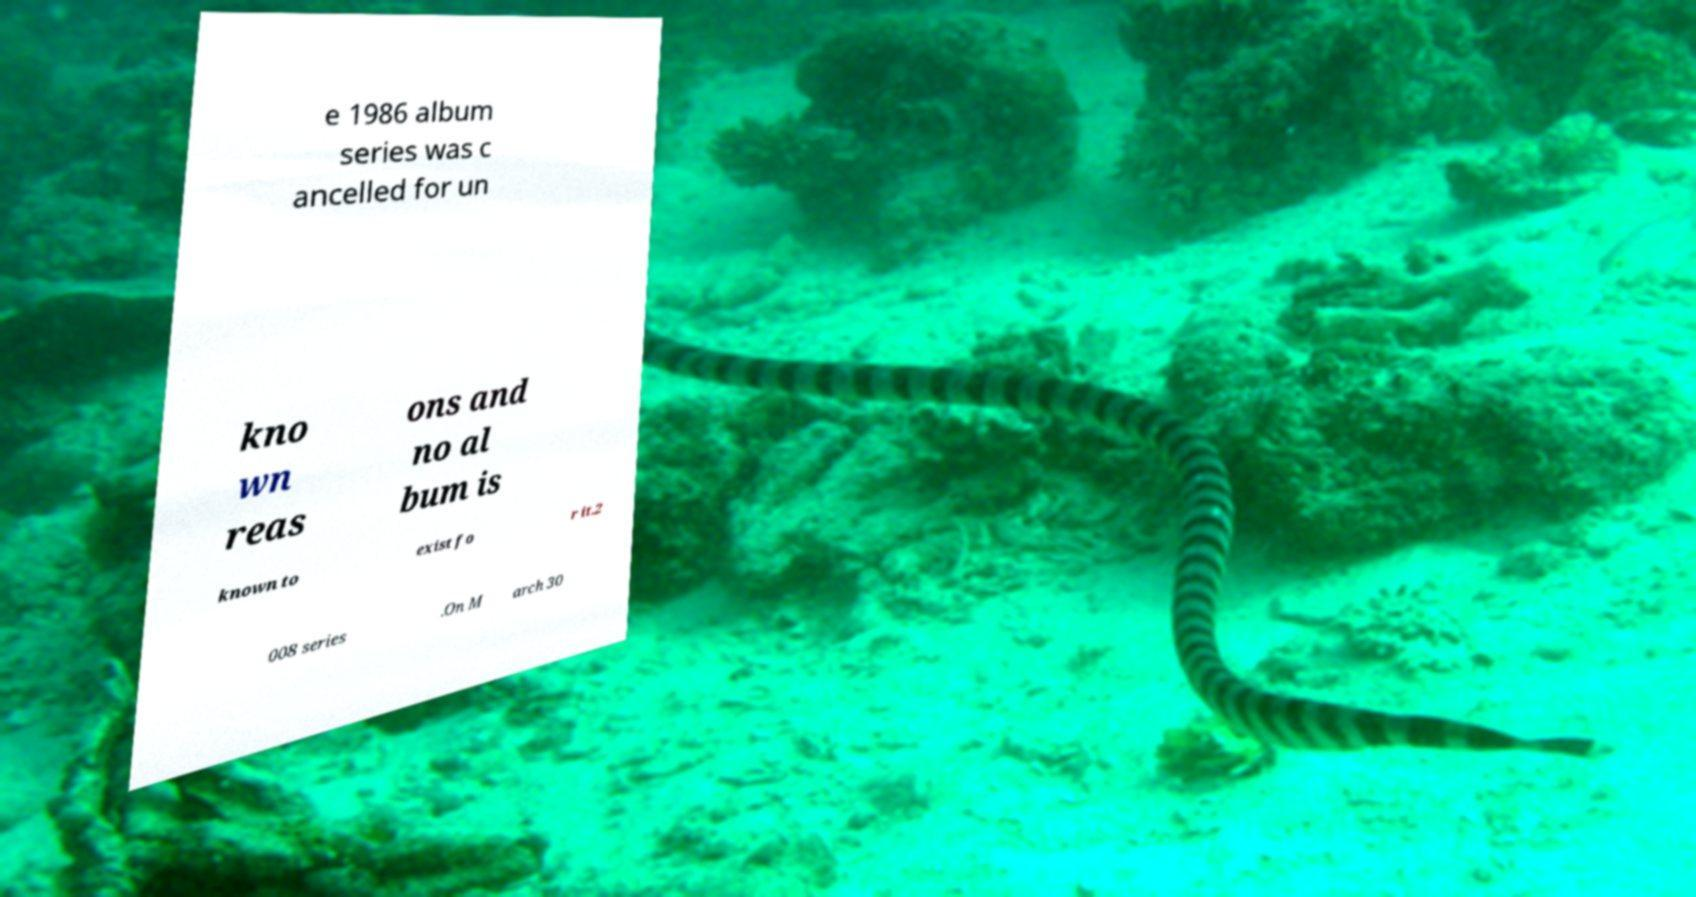Can you accurately transcribe the text from the provided image for me? e 1986 album series was c ancelled for un kno wn reas ons and no al bum is known to exist fo r it.2 008 series .On M arch 30 